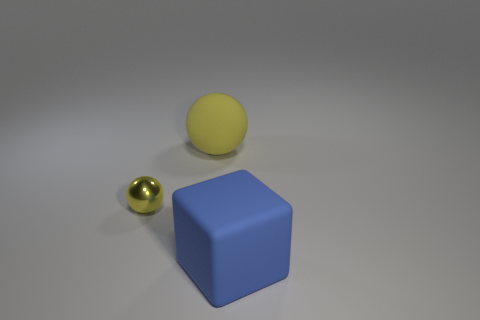Subtract all balls. How many objects are left? 1 Subtract 1 balls. How many balls are left? 1 Add 2 large things. How many objects exist? 5 Subtract all red blocks. Subtract all purple cylinders. How many blocks are left? 1 Subtract all red balls. How many green blocks are left? 0 Subtract all small things. Subtract all blue cubes. How many objects are left? 1 Add 1 large yellow matte things. How many large yellow matte things are left? 2 Add 1 big brown balls. How many big brown balls exist? 1 Subtract 0 cyan cylinders. How many objects are left? 3 